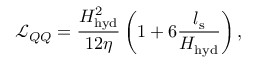<formula> <loc_0><loc_0><loc_500><loc_500>\mathcal { L } _ { Q Q } = \frac { H _ { h y d } ^ { 2 } } { 1 2 \eta } \left ( 1 + 6 \frac { l _ { s } } { H _ { h y d } } \right ) ,</formula> 